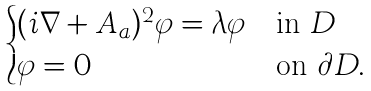Convert formula to latex. <formula><loc_0><loc_0><loc_500><loc_500>\begin{cases} ( i \nabla + A _ { a } ) ^ { 2 } \varphi = \lambda \varphi & \text {in } D \\ \varphi = 0 & \text {on } \partial D . \end{cases}</formula> 